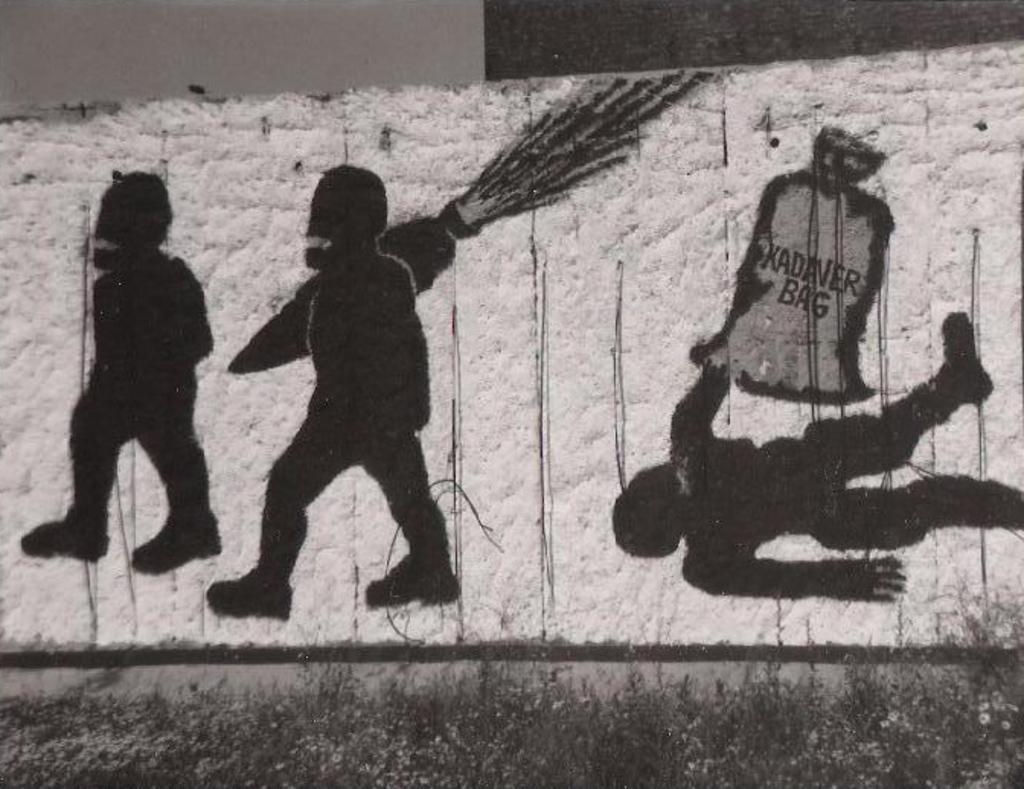How would you summarize this image in a sentence or two? In this image there is a painting on the wall with white color background. As we can see there is a painting of two persons on the left side of this image, and one person is on the right side of this image. This person is holding a bag, and the person standing on in the middle of this image is holding a carrot. 